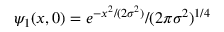Convert formula to latex. <formula><loc_0><loc_0><loc_500><loc_500>\psi _ { 1 } ( x , 0 ) = e ^ { - x ^ { 2 } / ( 2 \sigma ^ { 2 } ) } / ( 2 \pi \sigma ^ { 2 } ) ^ { 1 / 4 }</formula> 